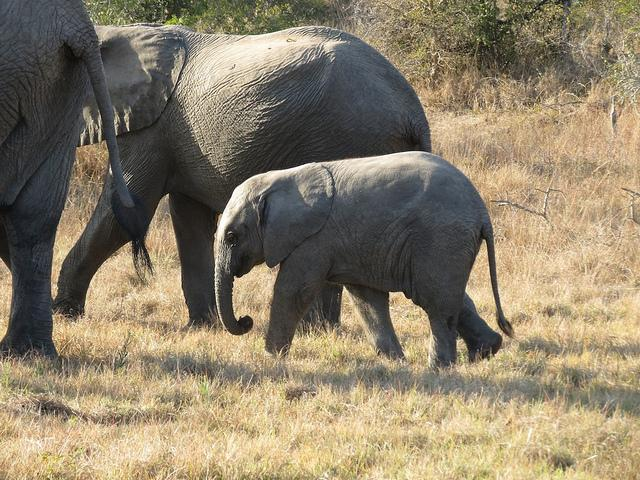How many little elephants are following behind the big elephant to the left? two 